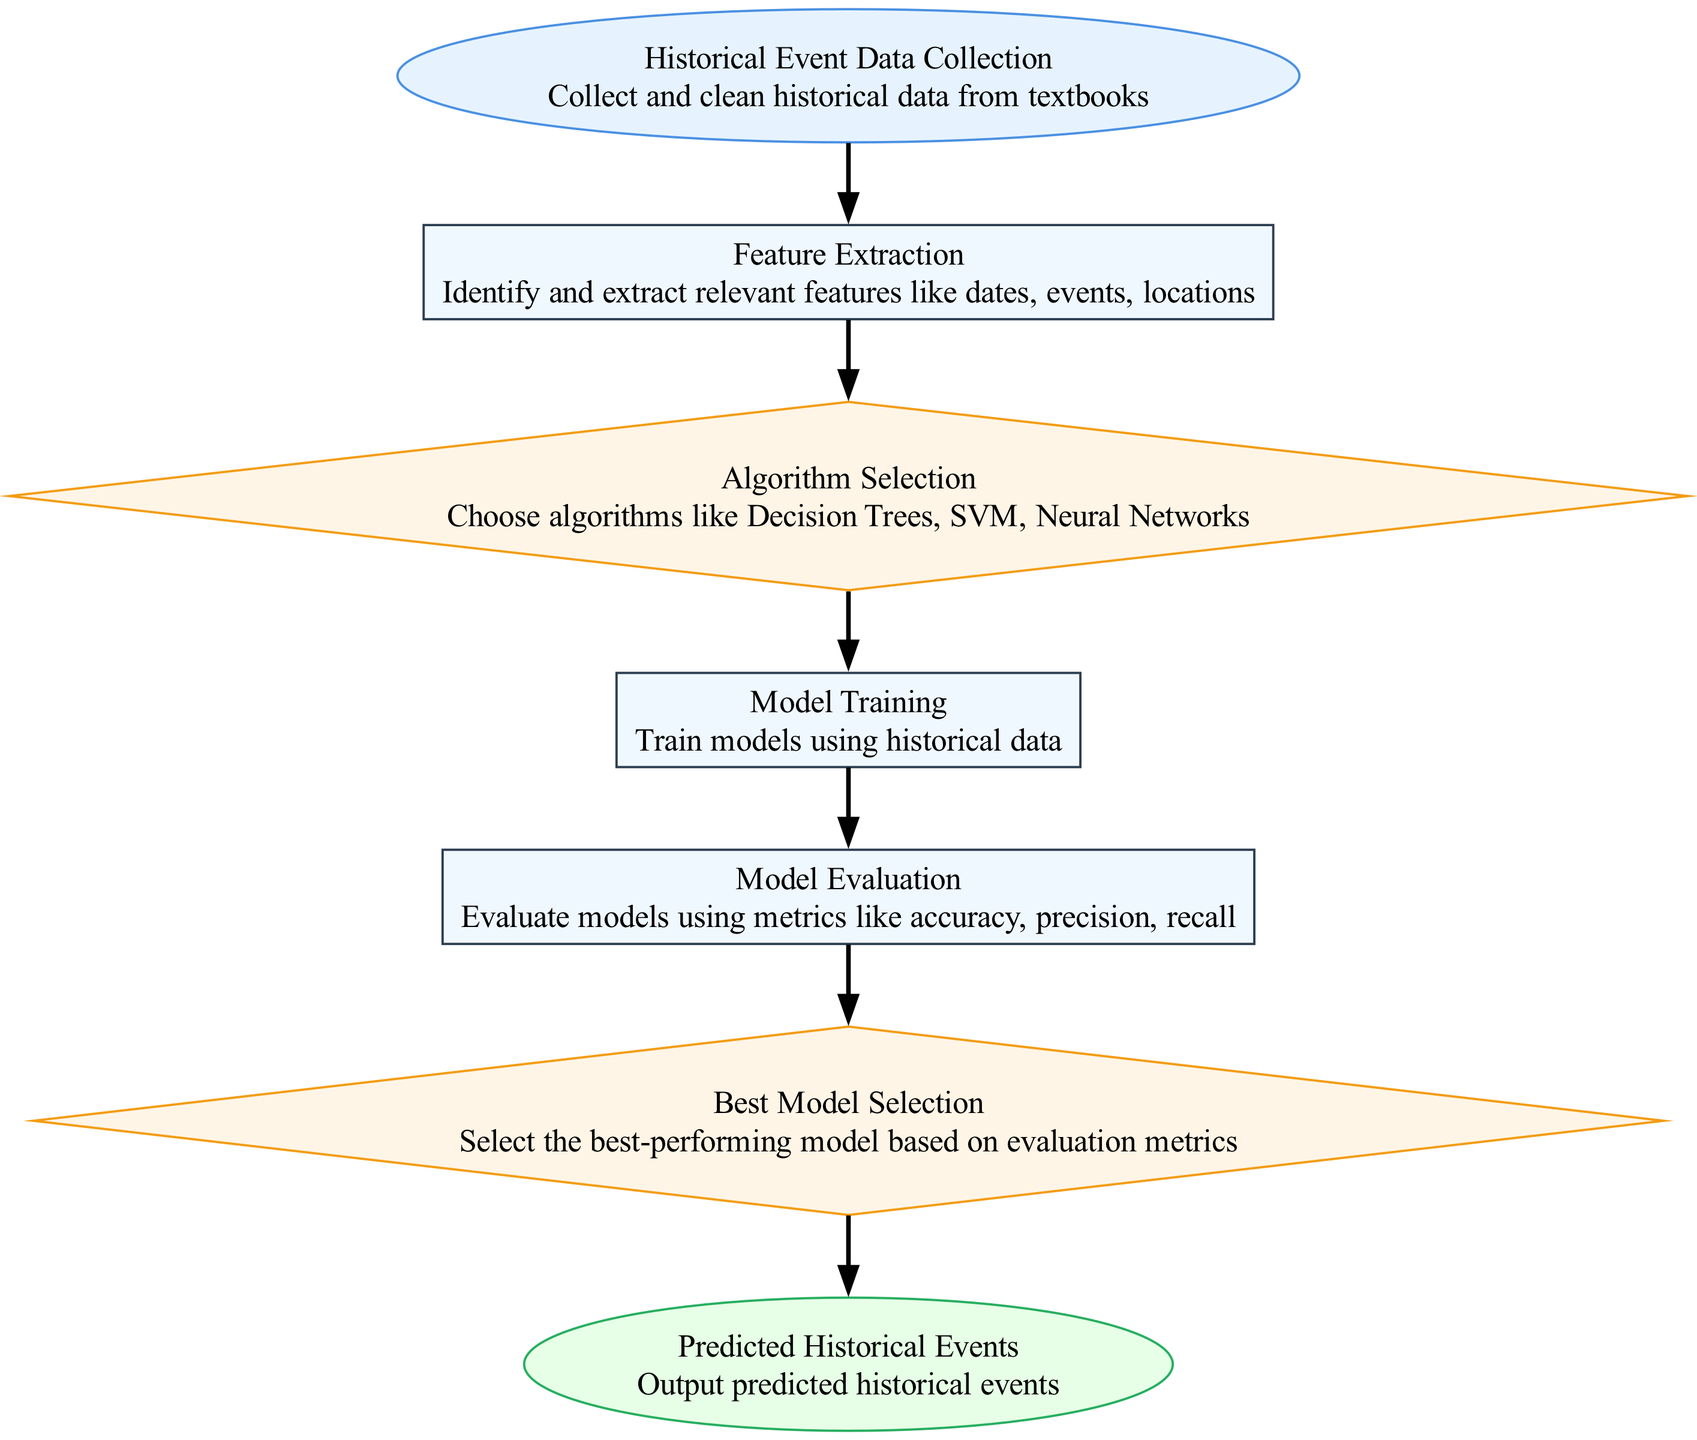What is the first stage in the diagram? The first stage or node in the diagram is labeled "Historical Event Data Collection," which indicates the initial step in the process where historical data from textbooks is collected and cleaned.
Answer: Historical Event Data Collection How many total nodes are present in the diagram? By counting the nodes listed in the data, there are a total of seven nodes in the diagram representing different stages and processes.
Answer: 7 What type of node is "Model Evaluation"? In the diagram, "Model Evaluation" is classified as a process node, indicating that it represents a step in the workflow where models are assessed using various metrics.
Answer: process Which node leads to "Best Model Selection"? The node that leads to "Best Model Selection" is "Model Evaluation," as it evaluates the models and then determines which one performs best based on those evaluations.
Answer: Model Evaluation What is the output of the diagram? The final output of the diagram, indicated by the last node, is "Predicted Historical Events," which suggests the result of the machine learning process being carried out.
Answer: Predicted Historical Events What is the purpose of the "Feature Extraction" stage? The "Feature Extraction" stage serves the purpose of identifying and extracting relevant features from the historical data, such as dates, events, and locations, to be used in model building.
Answer: Identify and extract relevant features How does the diagram represent decision points? Decision points in the diagram are represented as diamond-shaped nodes, which typically indicate where a choice must be made, such as selecting algorithms or identifying the best model.
Answer: diamond-shaped nodes Which algorithm types are considered in the "Algorithm Selection"? The algorithms mentioned in the "Algorithm Selection" node include Decision Trees, Support Vector Machines (SVM), and Neural Networks, indicating a variety of methods for prediction.
Answer: Decision Trees, SVM, Neural Networks What is the relationship between "Model Training" and "Model Evaluation"? The relationship is sequential; "Model Training" occurs first as the models are trained on historical data before moving on to "Model Evaluation," where those trained models are assessed for performance.
Answer: Sequential relationship 